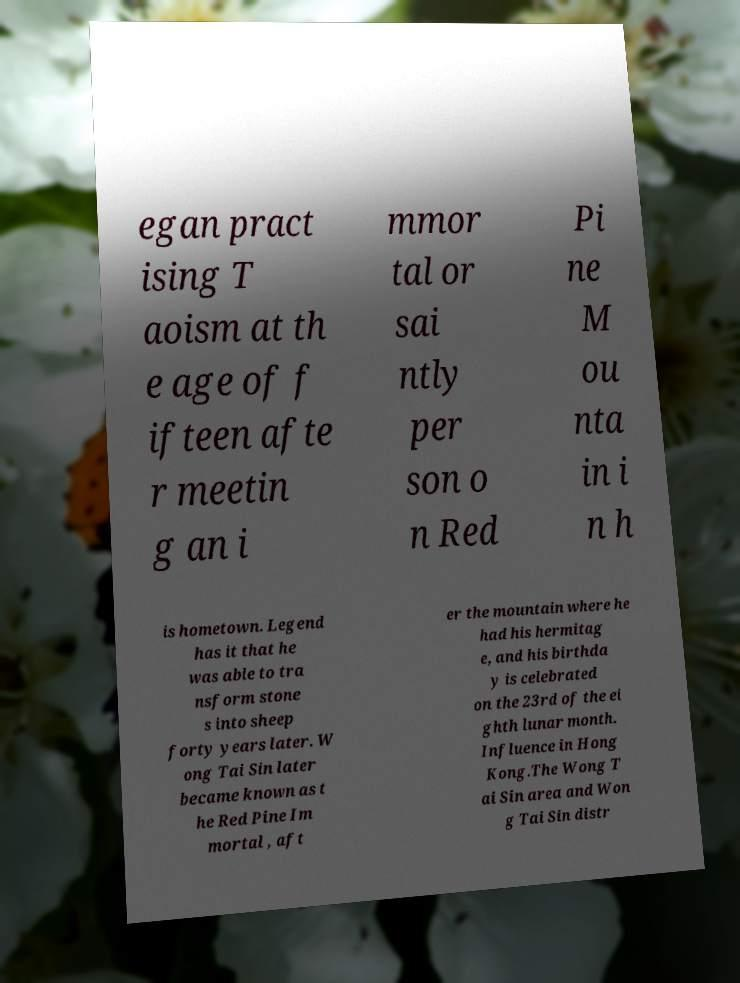Could you assist in decoding the text presented in this image and type it out clearly? egan pract ising T aoism at th e age of f ifteen afte r meetin g an i mmor tal or sai ntly per son o n Red Pi ne M ou nta in i n h is hometown. Legend has it that he was able to tra nsform stone s into sheep forty years later. W ong Tai Sin later became known as t he Red Pine Im mortal , aft er the mountain where he had his hermitag e, and his birthda y is celebrated on the 23rd of the ei ghth lunar month. Influence in Hong Kong.The Wong T ai Sin area and Won g Tai Sin distr 